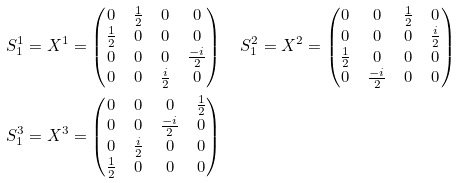Convert formula to latex. <formula><loc_0><loc_0><loc_500><loc_500>& S ^ { 1 } _ { 1 } = X ^ { 1 } = \begin{pmatrix} 0 & \frac { 1 } { 2 } & 0 & 0 \\ \frac { 1 } { 2 } & 0 & 0 & 0 \\ 0 & 0 & 0 & \frac { - i } { 2 } \\ 0 & 0 & \frac { i } { 2 } & 0 \end{pmatrix} \quad S ^ { 2 } _ { 1 } = X ^ { 2 } = \begin{pmatrix} 0 & 0 & \frac { 1 } { 2 } & 0 \\ 0 & 0 & 0 & \frac { i } { 2 } \\ \frac { 1 } { 2 } & 0 & 0 & 0 \\ 0 & \frac { - i } { 2 } & 0 & 0 \end{pmatrix} \\ & S ^ { 3 } _ { 1 } = X ^ { 3 } = \begin{pmatrix} 0 & 0 & 0 & \frac { 1 } { 2 } \\ 0 & 0 & \frac { - i } { 2 } & 0 \\ 0 & \frac { i } { 2 } & 0 & 0 \\ \frac { 1 } { 2 } & 0 & 0 & 0 \end{pmatrix}</formula> 